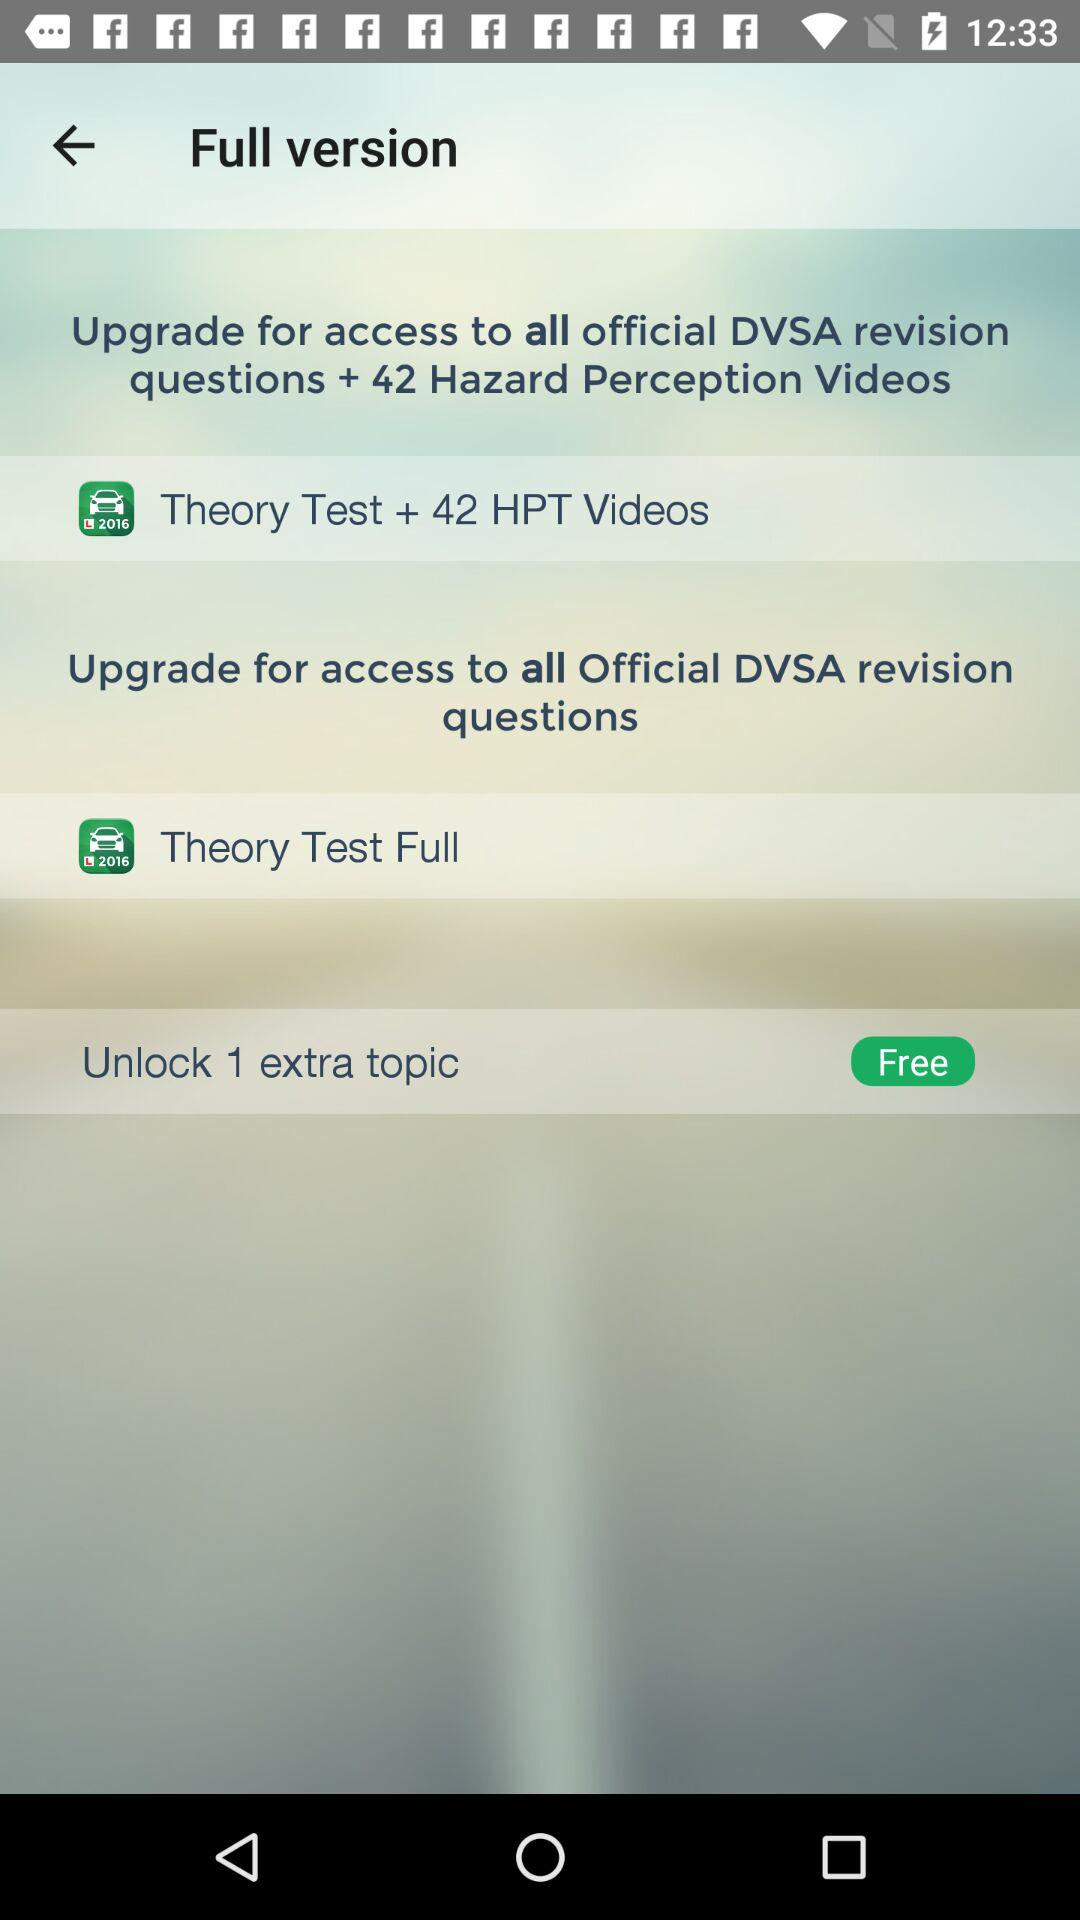How much HPT can be accessed with the upgraded version of the application? With the upgraded version of the application, 42 HPT can be accessed. 